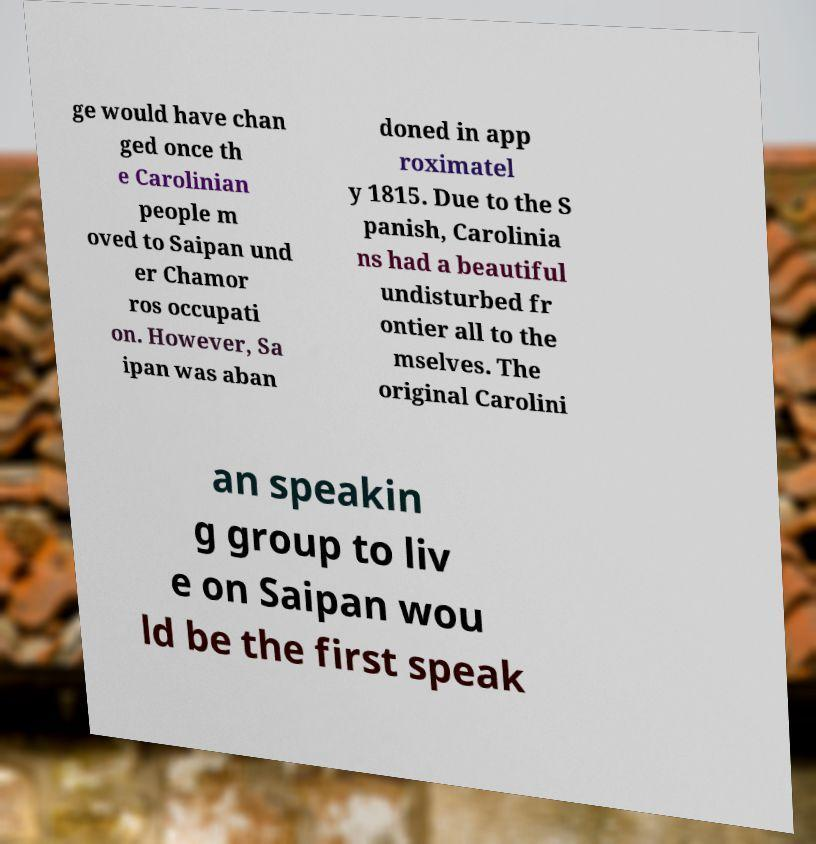There's text embedded in this image that I need extracted. Can you transcribe it verbatim? ge would have chan ged once th e Carolinian people m oved to Saipan und er Chamor ros occupati on. However, Sa ipan was aban doned in app roximatel y 1815. Due to the S panish, Carolinia ns had a beautiful undisturbed fr ontier all to the mselves. The original Carolini an speakin g group to liv e on Saipan wou ld be the first speak 